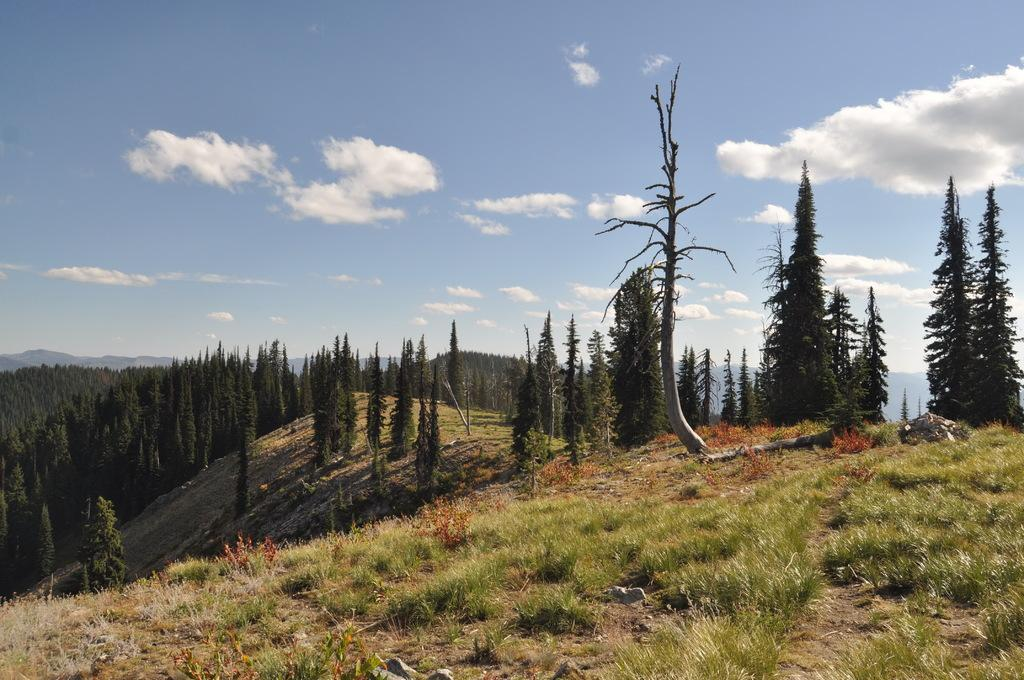What type of vegetation can be seen in the image? There are trees and grass in the image. What other natural elements are present in the image? There are stones and mountains in the image. What is visible in the background of the image? The sky is visible in the background of the image. What can be seen in the sky? Clouds are present in the sky. What type of shoes can be seen hanging from the trees in the image? There are no shoes present in the image; it only features trees, grass, stones, mountains, the sky, and clouds. 